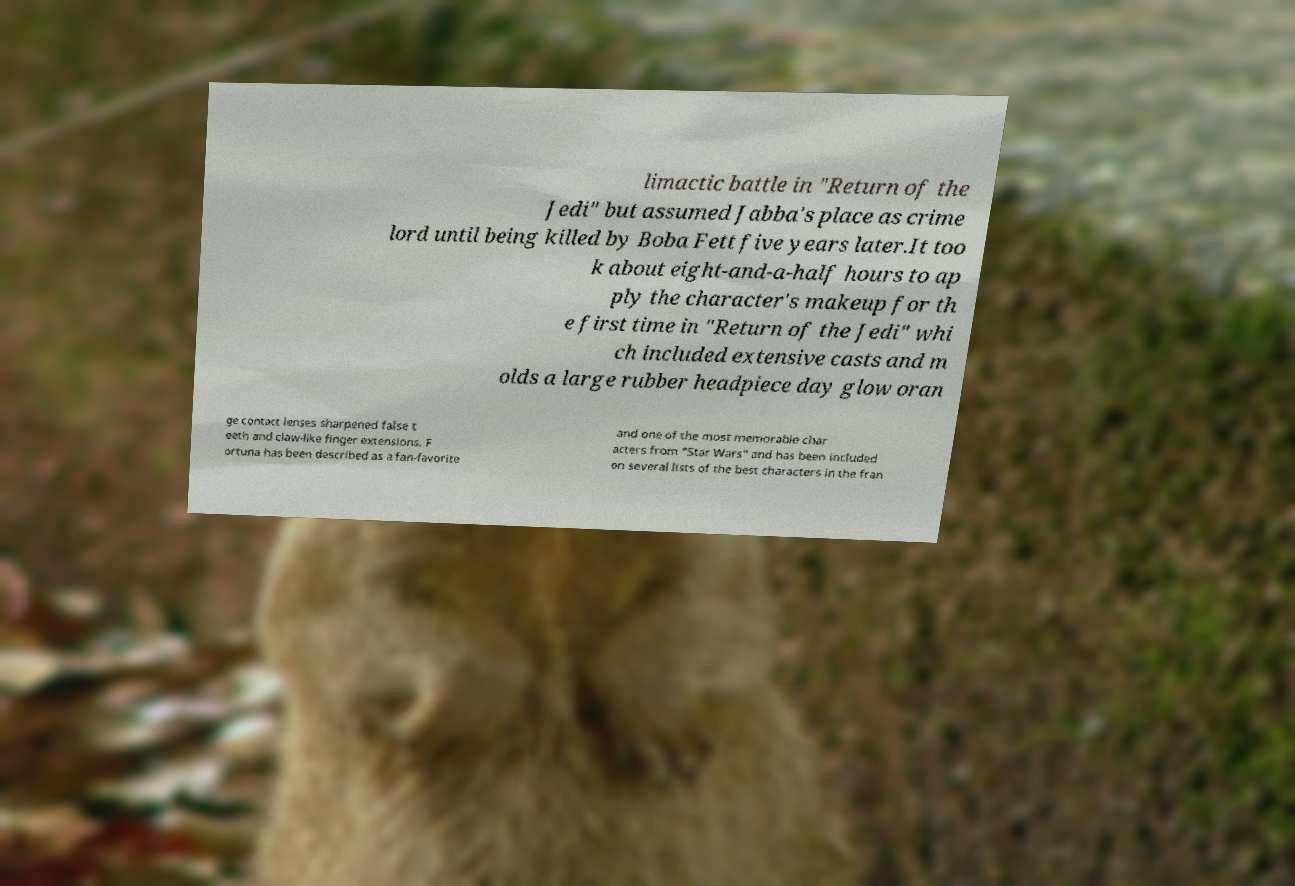Please identify and transcribe the text found in this image. limactic battle in "Return of the Jedi" but assumed Jabba's place as crime lord until being killed by Boba Fett five years later.It too k about eight-and-a-half hours to ap ply the character's makeup for th e first time in "Return of the Jedi" whi ch included extensive casts and m olds a large rubber headpiece day glow oran ge contact lenses sharpened false t eeth and claw-like finger extensions. F ortuna has been described as a fan-favorite and one of the most memorable char acters from "Star Wars" and has been included on several lists of the best characters in the fran 